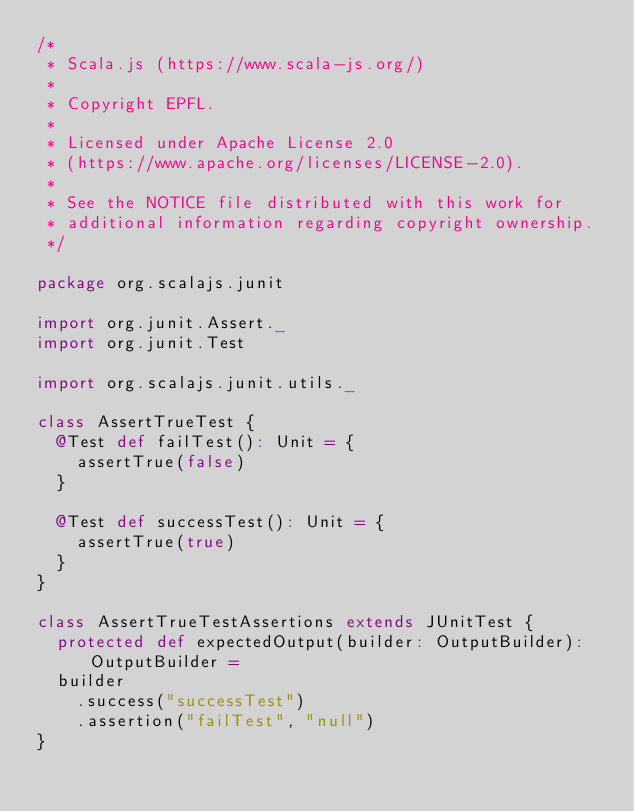<code> <loc_0><loc_0><loc_500><loc_500><_Scala_>/*
 * Scala.js (https://www.scala-js.org/)
 *
 * Copyright EPFL.
 *
 * Licensed under Apache License 2.0
 * (https://www.apache.org/licenses/LICENSE-2.0).
 *
 * See the NOTICE file distributed with this work for
 * additional information regarding copyright ownership.
 */

package org.scalajs.junit

import org.junit.Assert._
import org.junit.Test

import org.scalajs.junit.utils._

class AssertTrueTest {
  @Test def failTest(): Unit = {
    assertTrue(false)
  }

  @Test def successTest(): Unit = {
    assertTrue(true)
  }
}

class AssertTrueTestAssertions extends JUnitTest {
  protected def expectedOutput(builder: OutputBuilder): OutputBuilder =
  builder
    .success("successTest")
    .assertion("failTest", "null")
}
</code> 